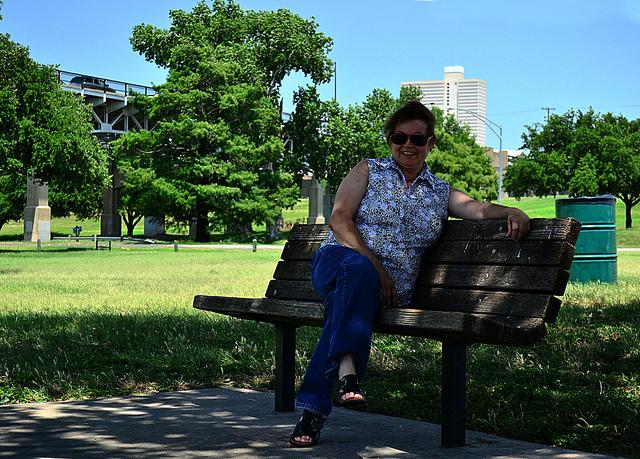What outdoor area is the woman sitting in? Please explain your reasoning. park. The woman is sitting on a bench in a grassy area so she is at a park. 